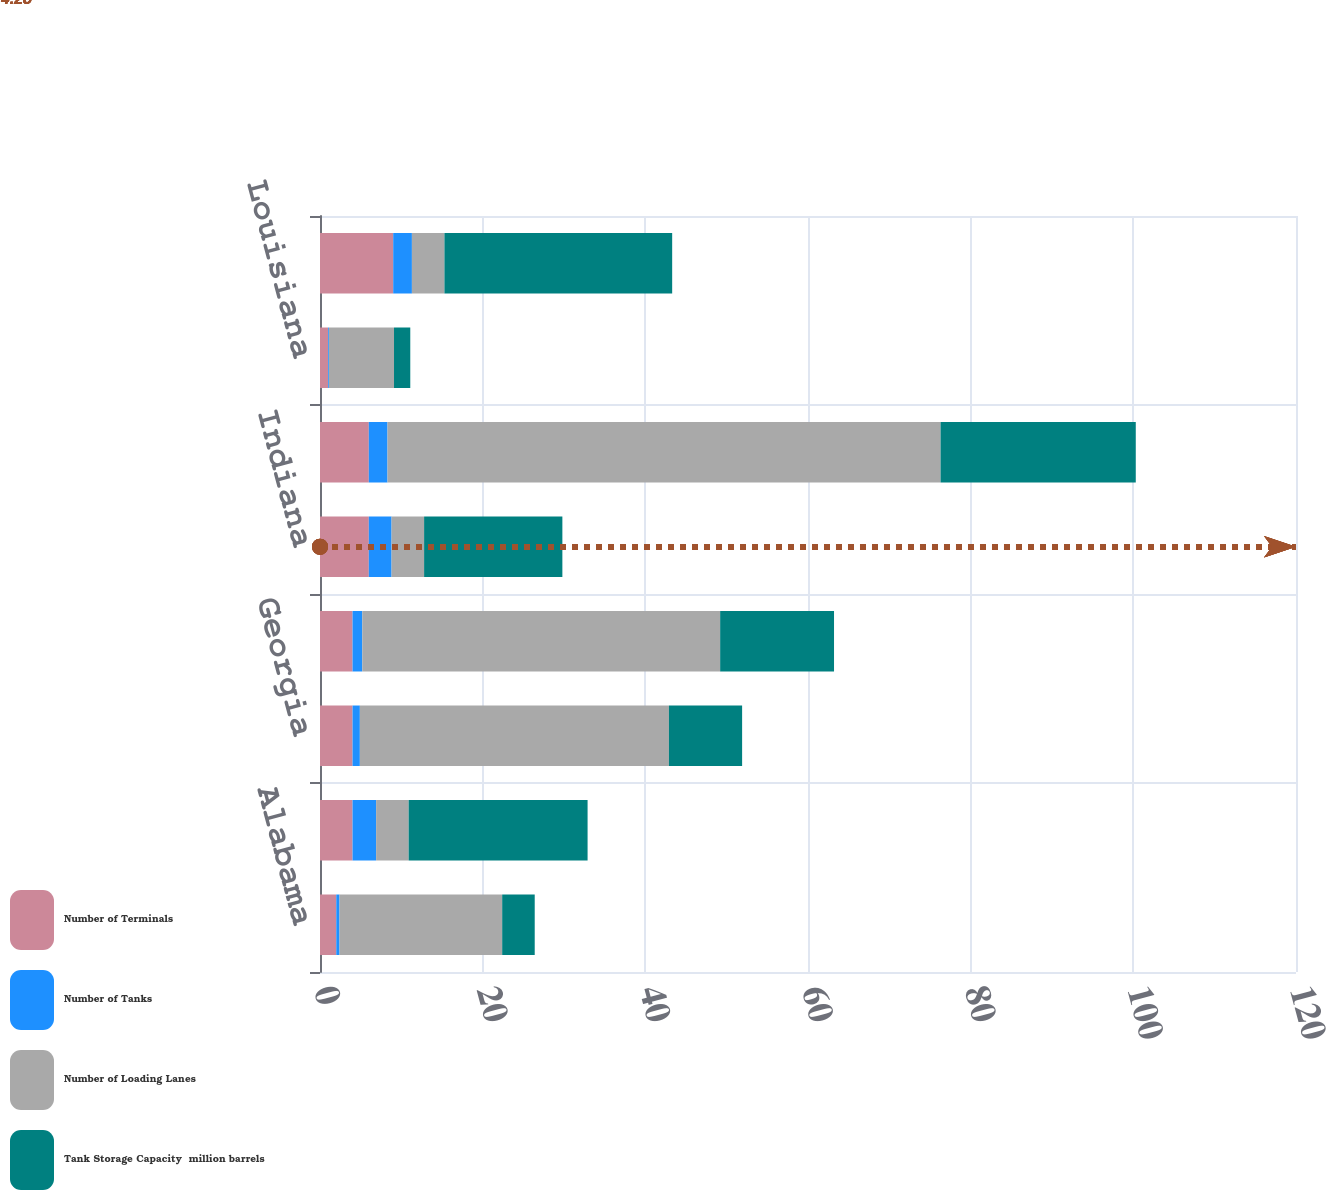Convert chart. <chart><loc_0><loc_0><loc_500><loc_500><stacked_bar_chart><ecel><fcel>Alabama<fcel>Florida<fcel>Georgia<fcel>Illinois<fcel>Indiana<fcel>Kentucky<fcel>Louisiana<fcel>Michigan<nl><fcel>Number of Terminals<fcel>2<fcel>4<fcel>4<fcel>4<fcel>6<fcel>6<fcel>1<fcel>9<nl><fcel>Number of Tanks<fcel>0.4<fcel>2.9<fcel>0.9<fcel>1.2<fcel>2.8<fcel>2.3<fcel>0.1<fcel>2.3<nl><fcel>Number of Loading Lanes<fcel>20<fcel>4<fcel>38<fcel>44<fcel>4<fcel>68<fcel>8<fcel>4<nl><fcel>Tank Storage Capacity  million barrels<fcel>4<fcel>22<fcel>9<fcel>14<fcel>17<fcel>24<fcel>2<fcel>28<nl></chart> 